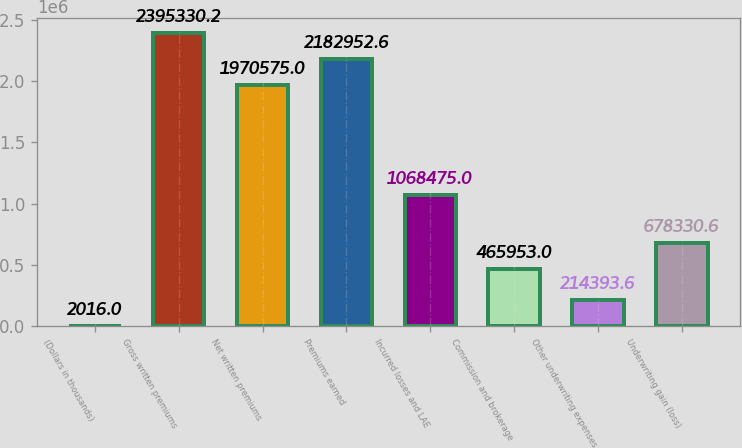<chart> <loc_0><loc_0><loc_500><loc_500><bar_chart><fcel>(Dollars in thousands)<fcel>Gross written premiums<fcel>Net written premiums<fcel>Premiums earned<fcel>Incurred losses and LAE<fcel>Commission and brokerage<fcel>Other underwriting expenses<fcel>Underwriting gain (loss)<nl><fcel>2016<fcel>2.39533e+06<fcel>1.97058e+06<fcel>2.18295e+06<fcel>1.06848e+06<fcel>465953<fcel>214394<fcel>678331<nl></chart> 